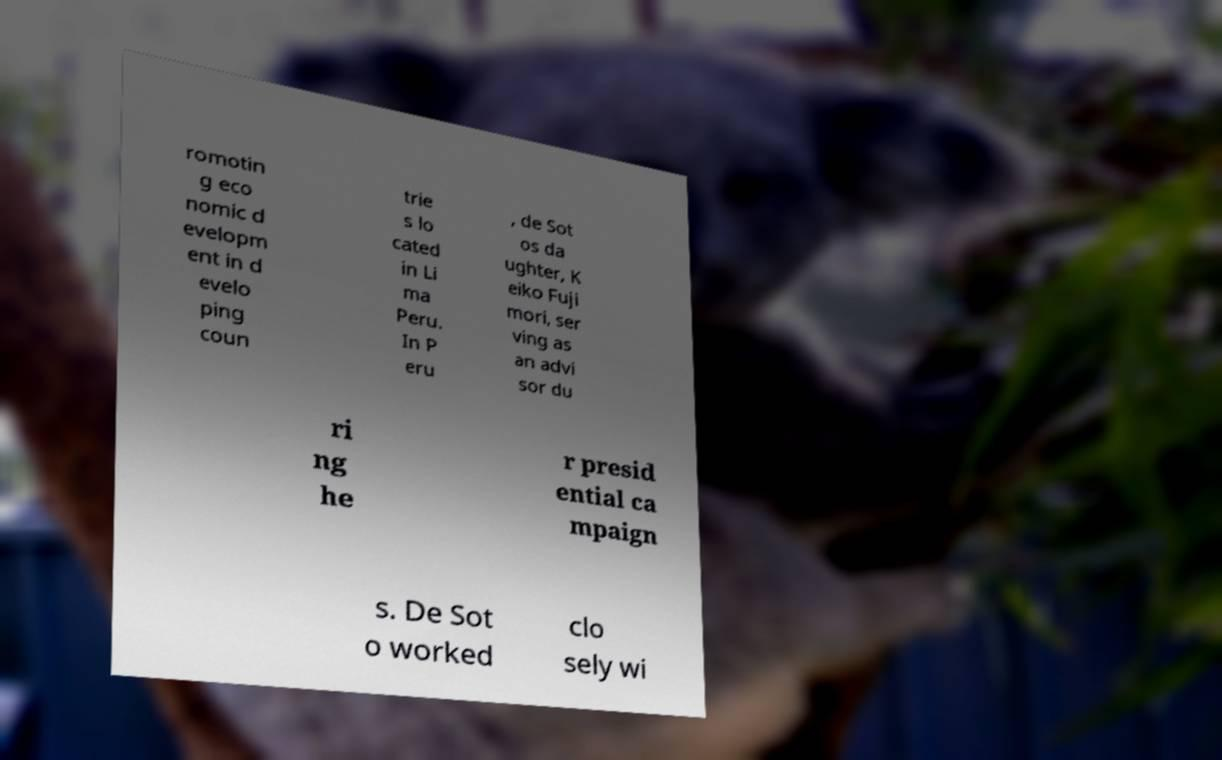Can you accurately transcribe the text from the provided image for me? romotin g eco nomic d evelopm ent in d evelo ping coun trie s lo cated in Li ma Peru. In P eru , de Sot os da ughter, K eiko Fuji mori, ser ving as an advi sor du ri ng he r presid ential ca mpaign s. De Sot o worked clo sely wi 